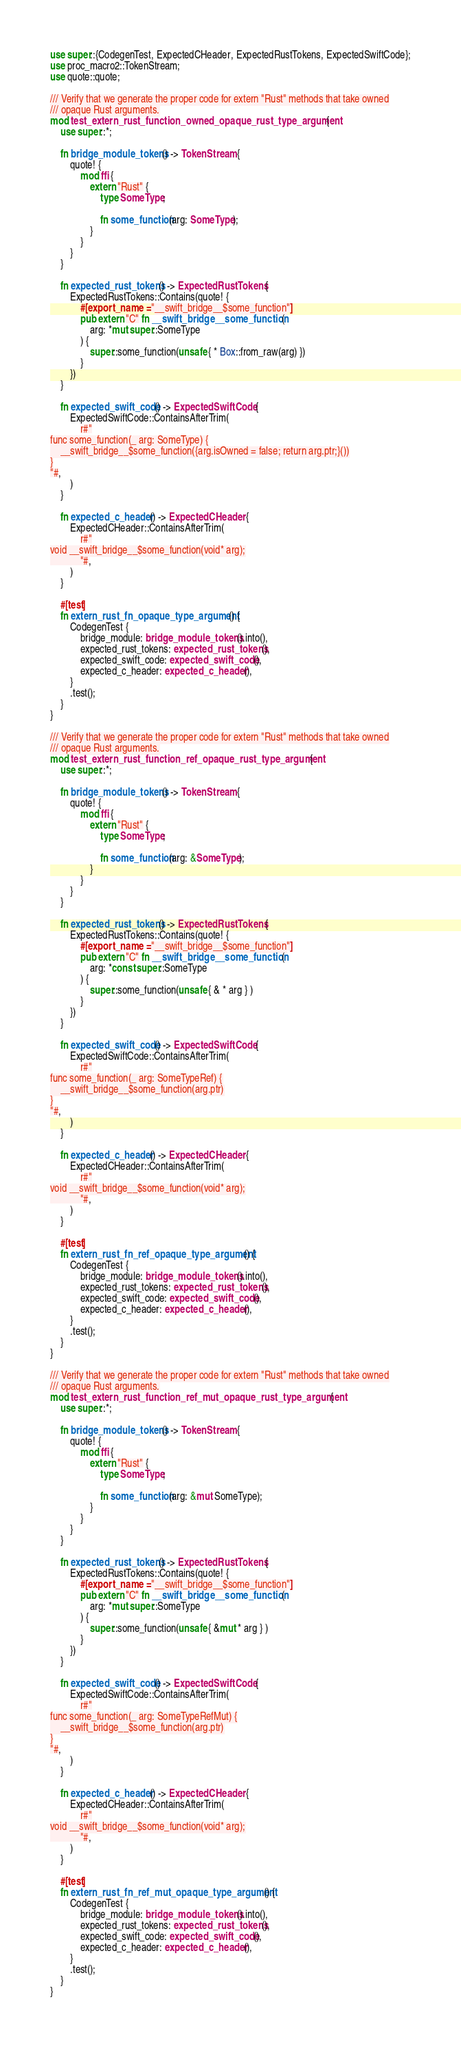<code> <loc_0><loc_0><loc_500><loc_500><_Rust_>use super::{CodegenTest, ExpectedCHeader, ExpectedRustTokens, ExpectedSwiftCode};
use proc_macro2::TokenStream;
use quote::quote;

/// Verify that we generate the proper code for extern "Rust" methods that take owned
/// opaque Rust arguments.
mod test_extern_rust_function_owned_opaque_rust_type_argument {
    use super::*;

    fn bridge_module_tokens() -> TokenStream {
        quote! {
            mod ffi {
                extern "Rust" {
                    type SomeType;

                    fn some_function(arg: SomeType);
                }
            }
        }
    }

    fn expected_rust_tokens() -> ExpectedRustTokens {
        ExpectedRustTokens::Contains(quote! {
            #[export_name = "__swift_bridge__$some_function"]
            pub extern "C" fn __swift_bridge__some_function (
                arg: *mut super::SomeType
            ) {
                super::some_function(unsafe { * Box::from_raw(arg) })
            }
        })
    }

    fn expected_swift_code() -> ExpectedSwiftCode {
        ExpectedSwiftCode::ContainsAfterTrim(
            r#"
func some_function(_ arg: SomeType) {
    __swift_bridge__$some_function({arg.isOwned = false; return arg.ptr;}())
}
"#,
        )
    }

    fn expected_c_header() -> ExpectedCHeader {
        ExpectedCHeader::ContainsAfterTrim(
            r#"
void __swift_bridge__$some_function(void* arg);
            "#,
        )
    }

    #[test]
    fn extern_rust_fn_opaque_type_argument() {
        CodegenTest {
            bridge_module: bridge_module_tokens().into(),
            expected_rust_tokens: expected_rust_tokens(),
            expected_swift_code: expected_swift_code(),
            expected_c_header: expected_c_header(),
        }
        .test();
    }
}

/// Verify that we generate the proper code for extern "Rust" methods that take owned
/// opaque Rust arguments.
mod test_extern_rust_function_ref_opaque_rust_type_argument {
    use super::*;

    fn bridge_module_tokens() -> TokenStream {
        quote! {
            mod ffi {
                extern "Rust" {
                    type SomeType;

                    fn some_function(arg: &SomeType);
                }
            }
        }
    }

    fn expected_rust_tokens() -> ExpectedRustTokens {
        ExpectedRustTokens::Contains(quote! {
            #[export_name = "__swift_bridge__$some_function"]
            pub extern "C" fn __swift_bridge__some_function (
                arg: *const super::SomeType
            ) {
                super::some_function(unsafe { & * arg } )
            }
        })
    }

    fn expected_swift_code() -> ExpectedSwiftCode {
        ExpectedSwiftCode::ContainsAfterTrim(
            r#"
func some_function(_ arg: SomeTypeRef) {
    __swift_bridge__$some_function(arg.ptr)
}
"#,
        )
    }

    fn expected_c_header() -> ExpectedCHeader {
        ExpectedCHeader::ContainsAfterTrim(
            r#"
void __swift_bridge__$some_function(void* arg);
            "#,
        )
    }

    #[test]
    fn extern_rust_fn_ref_opaque_type_argument() {
        CodegenTest {
            bridge_module: bridge_module_tokens().into(),
            expected_rust_tokens: expected_rust_tokens(),
            expected_swift_code: expected_swift_code(),
            expected_c_header: expected_c_header(),
        }
        .test();
    }
}

/// Verify that we generate the proper code for extern "Rust" methods that take owned
/// opaque Rust arguments.
mod test_extern_rust_function_ref_mut_opaque_rust_type_argument {
    use super::*;

    fn bridge_module_tokens() -> TokenStream {
        quote! {
            mod ffi {
                extern "Rust" {
                    type SomeType;

                    fn some_function(arg: &mut SomeType);
                }
            }
        }
    }

    fn expected_rust_tokens() -> ExpectedRustTokens {
        ExpectedRustTokens::Contains(quote! {
            #[export_name = "__swift_bridge__$some_function"]
            pub extern "C" fn __swift_bridge__some_function (
                arg: *mut super::SomeType
            ) {
                super::some_function(unsafe { &mut * arg } )
            }
        })
    }

    fn expected_swift_code() -> ExpectedSwiftCode {
        ExpectedSwiftCode::ContainsAfterTrim(
            r#"
func some_function(_ arg: SomeTypeRefMut) {
    __swift_bridge__$some_function(arg.ptr)
}
"#,
        )
    }

    fn expected_c_header() -> ExpectedCHeader {
        ExpectedCHeader::ContainsAfterTrim(
            r#"
void __swift_bridge__$some_function(void* arg);
            "#,
        )
    }

    #[test]
    fn extern_rust_fn_ref_mut_opaque_type_argument() {
        CodegenTest {
            bridge_module: bridge_module_tokens().into(),
            expected_rust_tokens: expected_rust_tokens(),
            expected_swift_code: expected_swift_code(),
            expected_c_header: expected_c_header(),
        }
        .test();
    }
}
</code> 